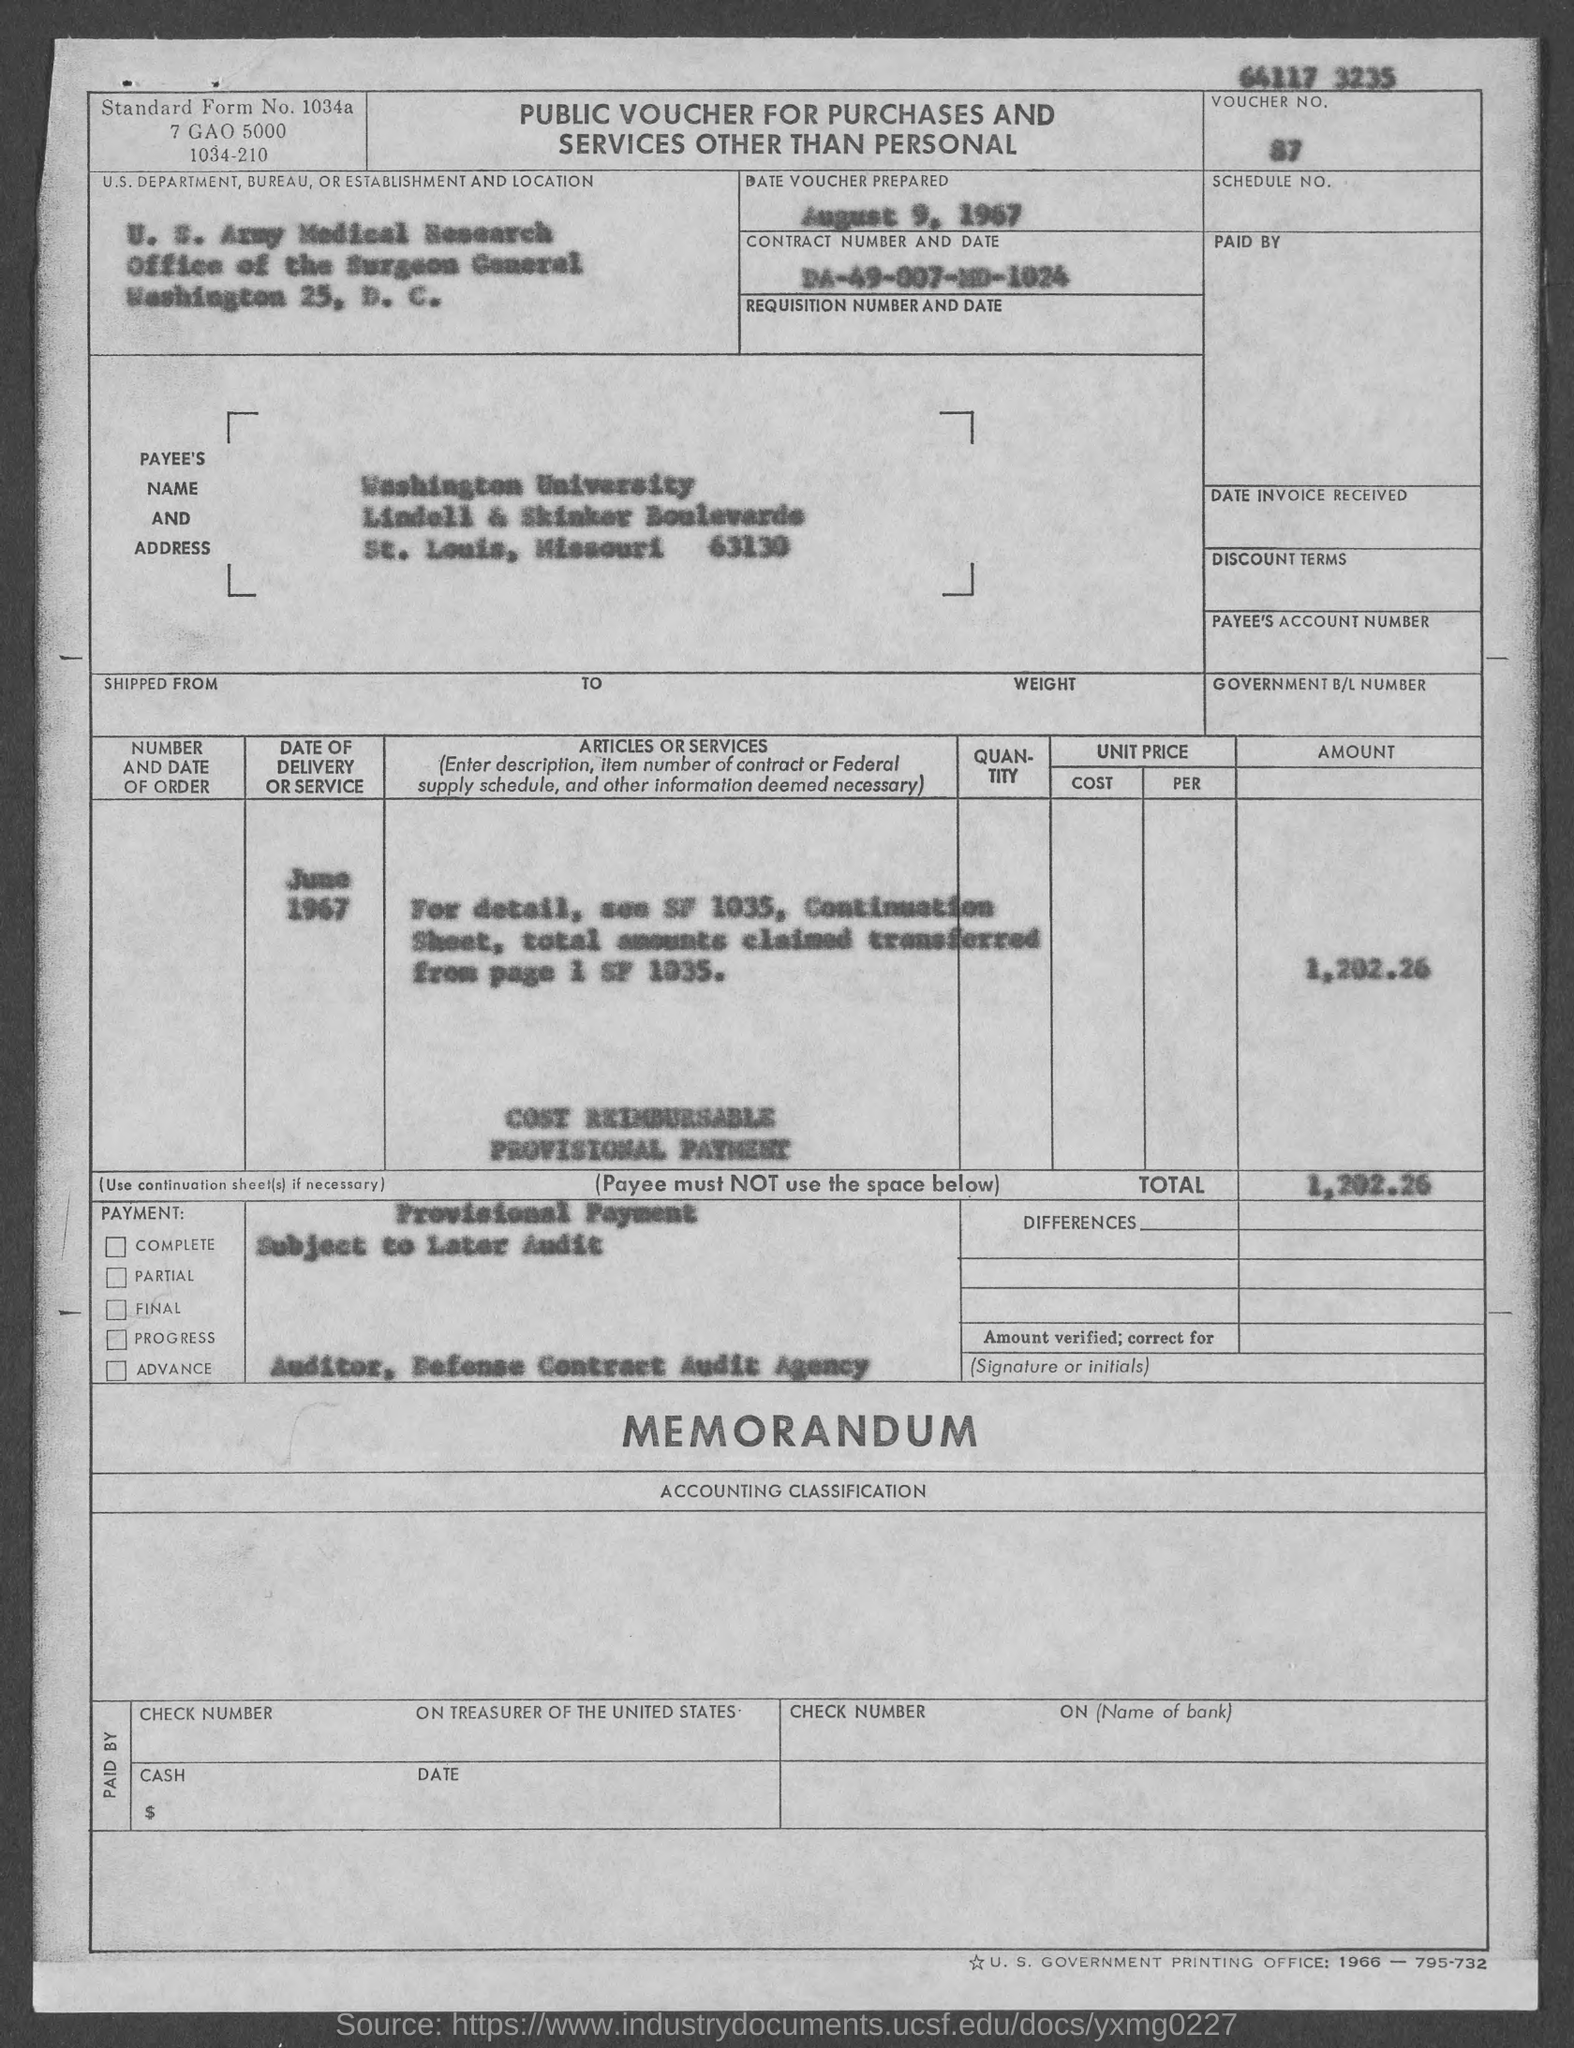Identify some key points in this picture. The voucher was prepared on August 9, 1967. The Contract No. is DA-49-007-MD-1024. The voucher number is 87. 